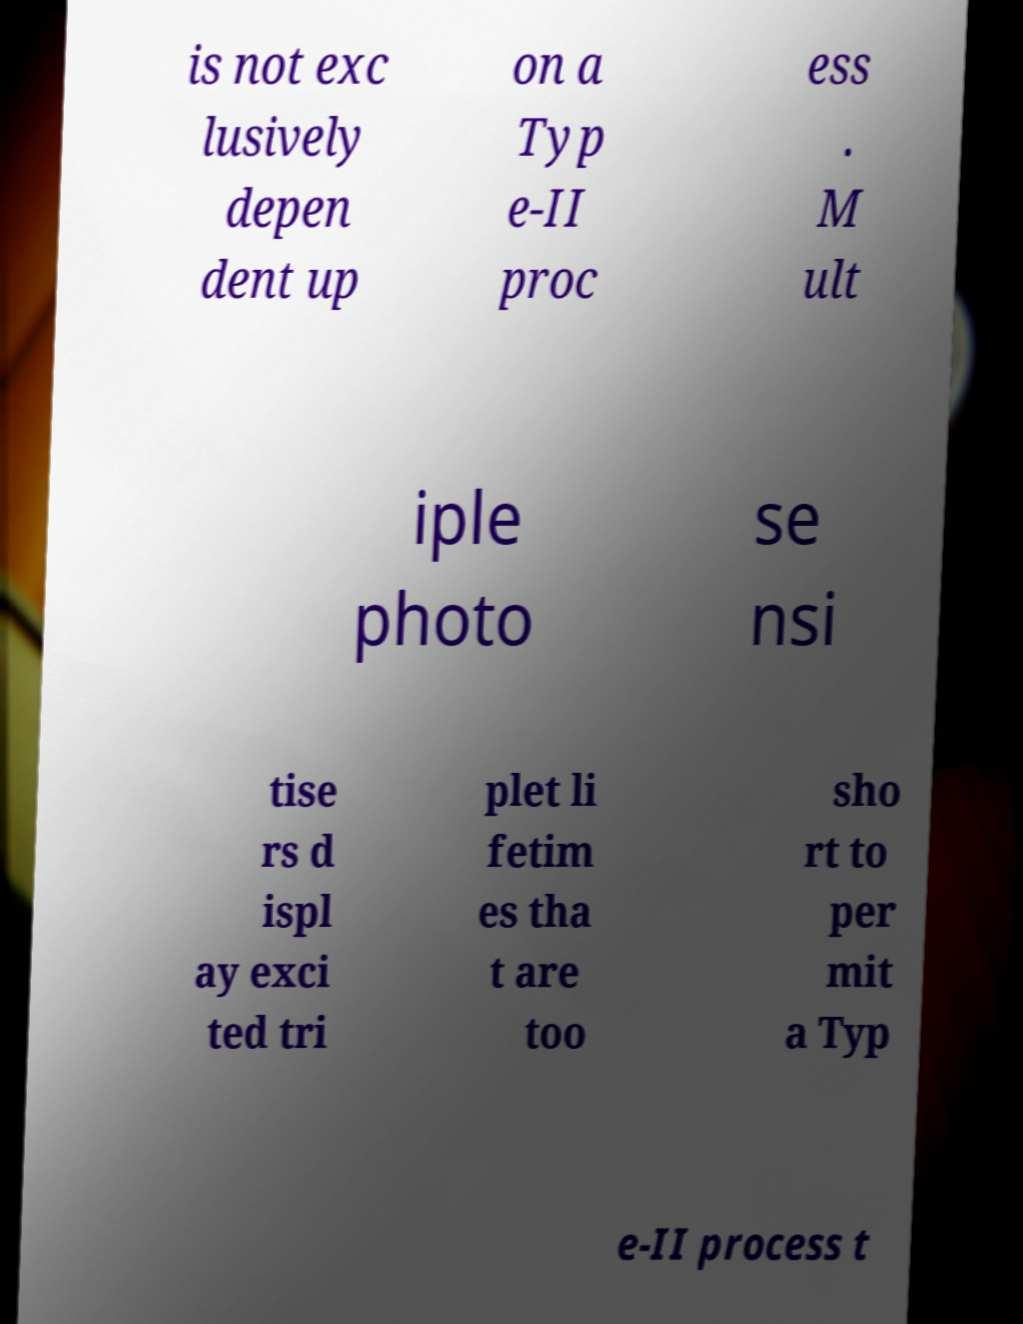I need the written content from this picture converted into text. Can you do that? is not exc lusively depen dent up on a Typ e-II proc ess . M ult iple photo se nsi tise rs d ispl ay exci ted tri plet li fetim es tha t are too sho rt to per mit a Typ e-II process t 